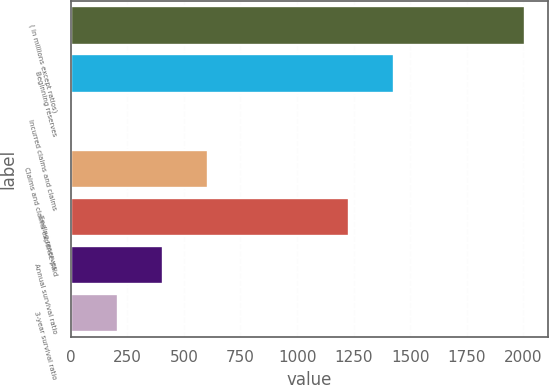<chart> <loc_0><loc_0><loc_500><loc_500><bar_chart><fcel>( in millions except ratios)<fcel>Beginning reserves<fcel>Incurred claims and claims<fcel>Claims and claims expense paid<fcel>Ending reserves<fcel>Annual survival ratio<fcel>3-year survival ratio<nl><fcel>2008<fcel>1428<fcel>8<fcel>608<fcel>1228<fcel>408<fcel>208<nl></chart> 